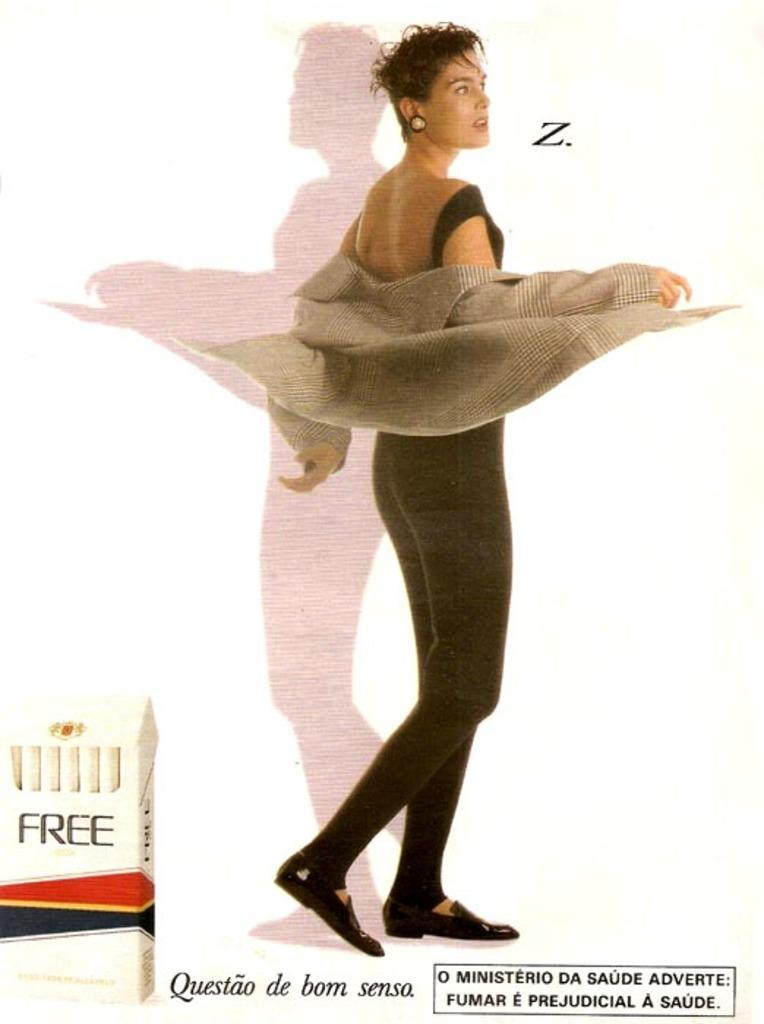What is the main subject of the image? There is a woman standing in the image. Can you describe any additional details about the woman? Unfortunately, the provided facts do not give any additional details about the woman. What is written or displayed at the bottom of the image? There is text visible at the bottom of the image. What type of dirt can be seen in the background of the image? There is no dirt visible in the image; it only features a woman standing and text at the bottom. 